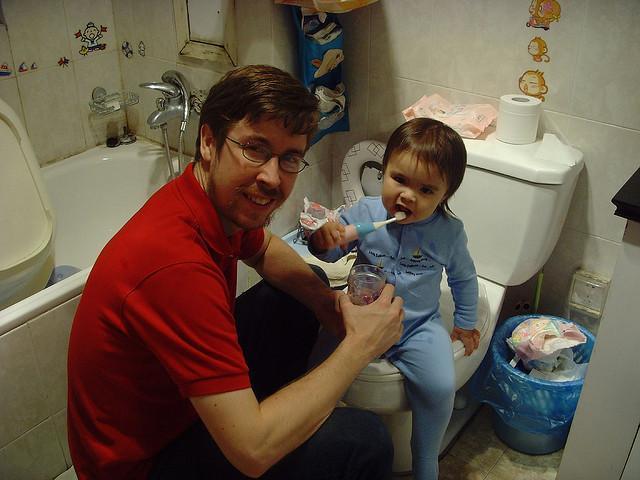How many toothbrushes is this?
Give a very brief answer. 1. How many sinks are there?
Give a very brief answer. 1. How many people are in the photo?
Give a very brief answer. 2. 